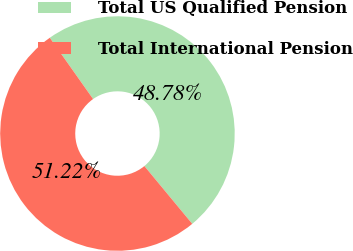Convert chart to OTSL. <chart><loc_0><loc_0><loc_500><loc_500><pie_chart><fcel>Total US Qualified Pension<fcel>Total International Pension<nl><fcel>48.78%<fcel>51.22%<nl></chart> 